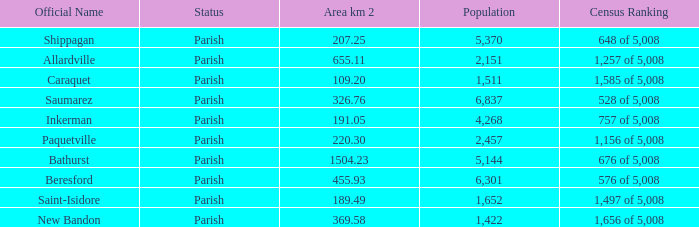What is the Area of the Saint-Isidore Parish with a Population smaller than 4,268? 189.49. 